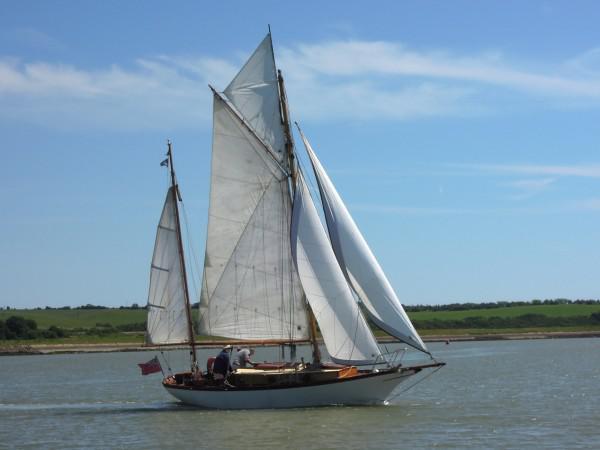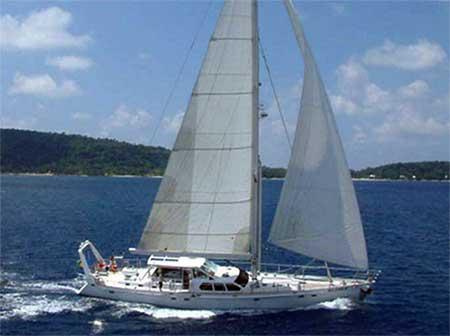The first image is the image on the left, the second image is the image on the right. Examine the images to the left and right. Is the description "One sailboat has a dark exterior and no more than four sails." accurate? Answer yes or no. No. The first image is the image on the left, the second image is the image on the right. Considering the images on both sides, is "The boat in the image on the right is lighter in color than the boat in the image on the left." valid? Answer yes or no. Yes. 